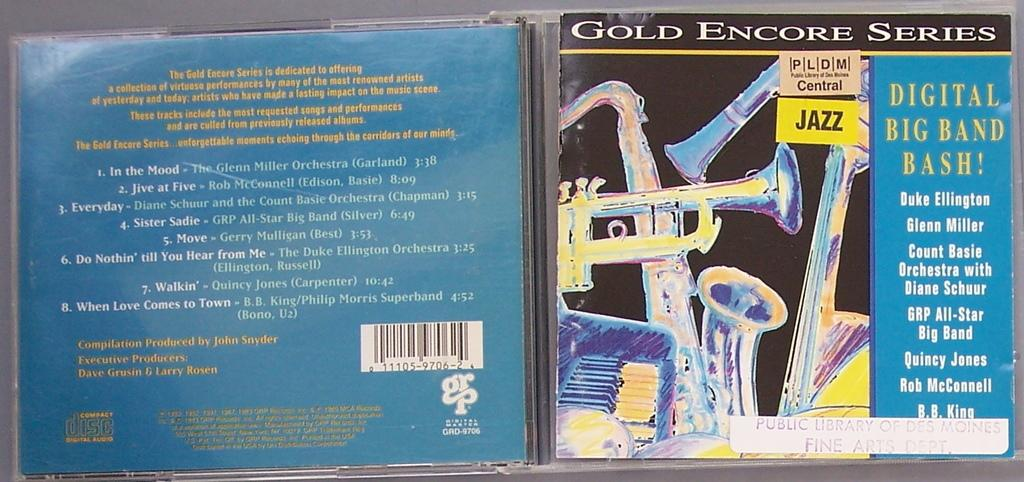<image>
Write a terse but informative summary of the picture. a cd of jazz showing the Gold encore series and the digital big band bash 